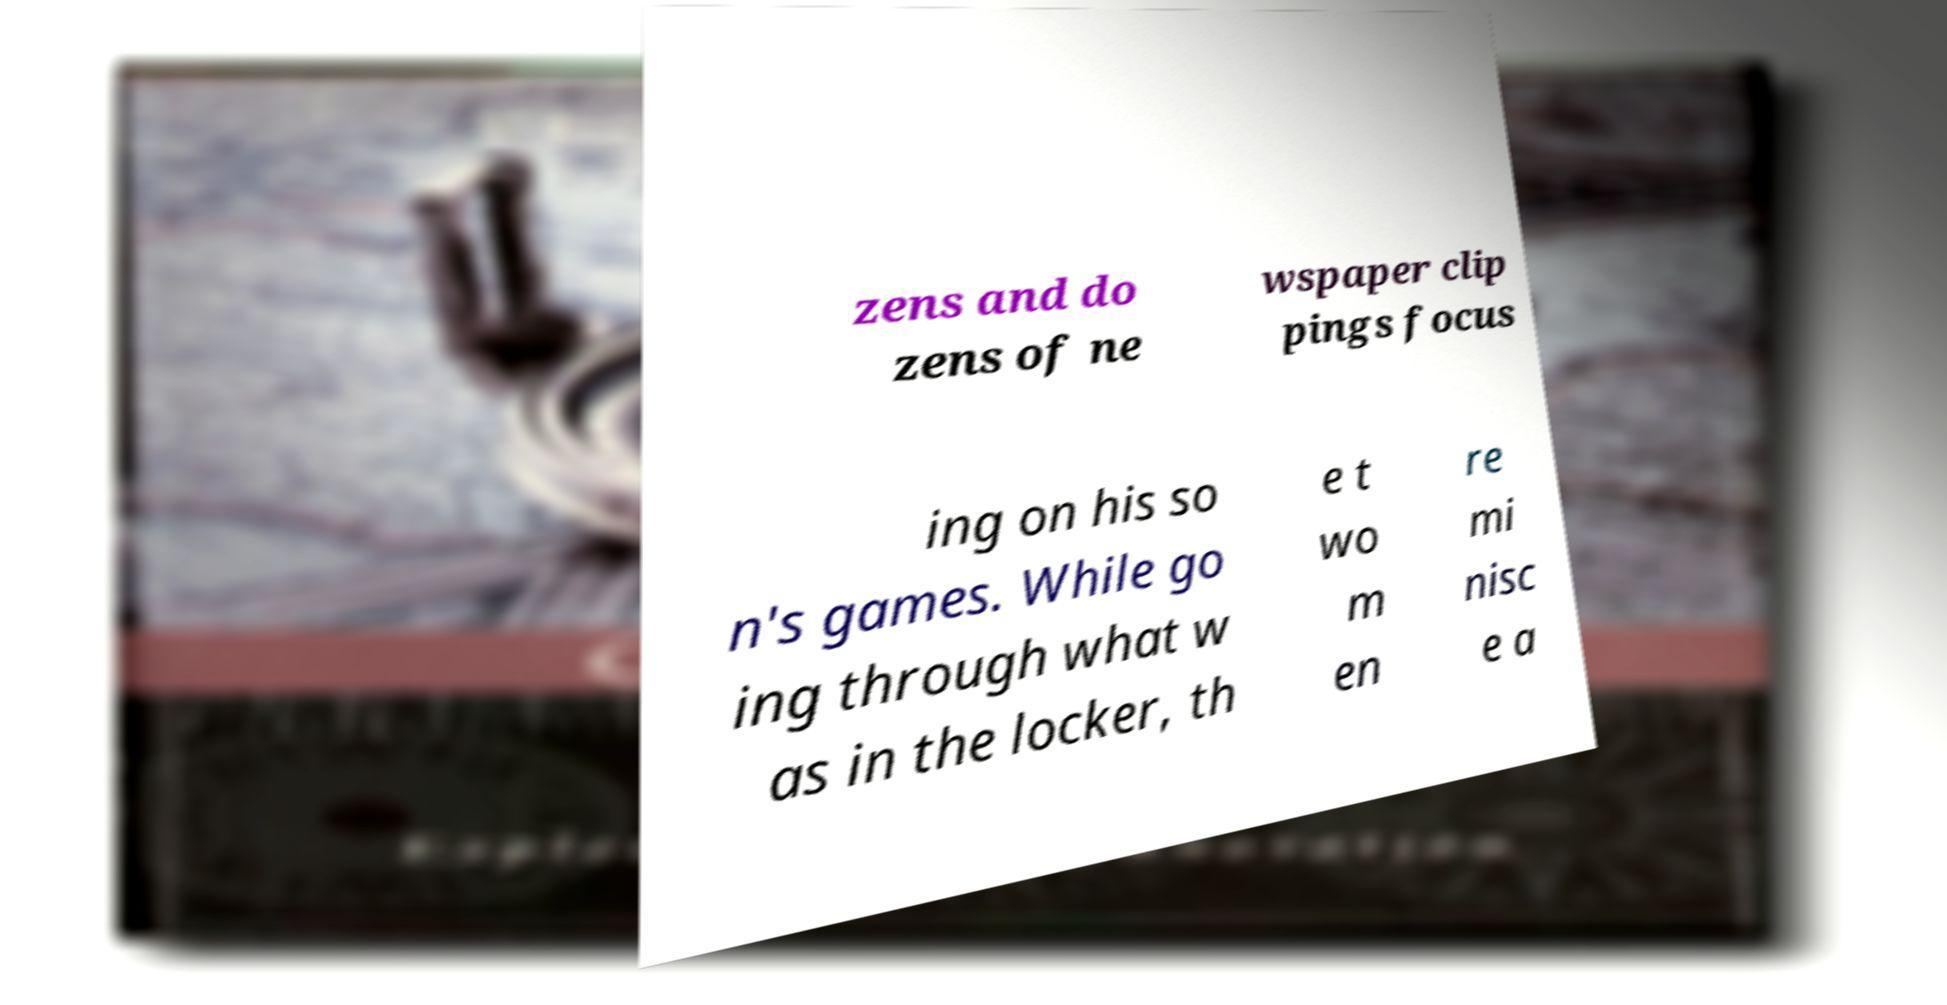Can you read and provide the text displayed in the image?This photo seems to have some interesting text. Can you extract and type it out for me? zens and do zens of ne wspaper clip pings focus ing on his so n's games. While go ing through what w as in the locker, th e t wo m en re mi nisc e a 